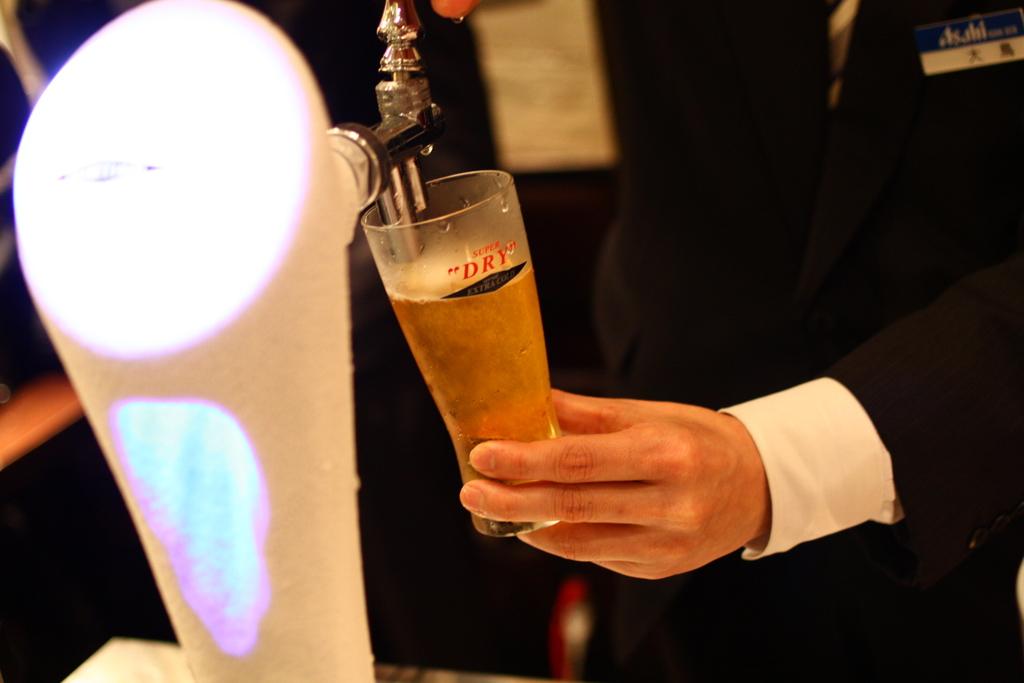What is on the glass?
Make the answer very short. Dry. 